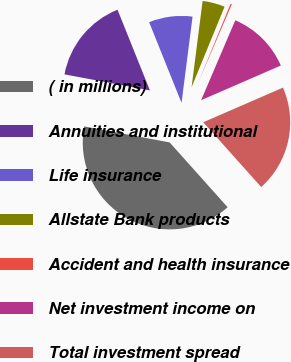<chart> <loc_0><loc_0><loc_500><loc_500><pie_chart><fcel>( in millions)<fcel>Annuities and institutional<fcel>Life insurance<fcel>Allstate Bank products<fcel>Accident and health insurance<fcel>Net investment income on<fcel>Total investment spread<nl><fcel>39.57%<fcel>15.97%<fcel>8.1%<fcel>4.17%<fcel>0.24%<fcel>12.04%<fcel>19.91%<nl></chart> 